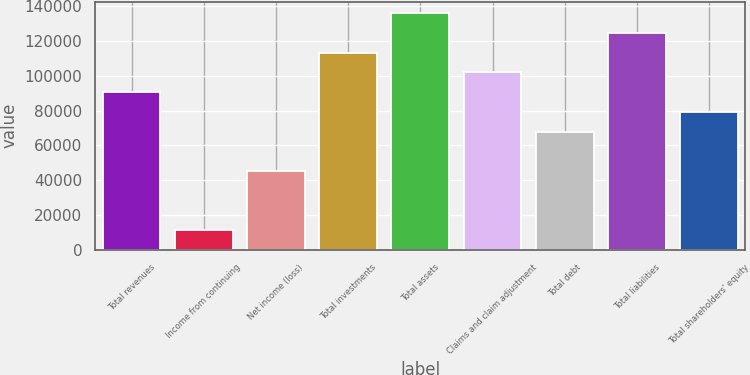<chart> <loc_0><loc_0><loc_500><loc_500><bar_chart><fcel>Total revenues<fcel>Income from continuing<fcel>Net income (loss)<fcel>Total investments<fcel>Total assets<fcel>Claims and claim adjustment<fcel>Total debt<fcel>Total liabilities<fcel>Total shareholders' equity<nl><fcel>90549.8<fcel>11319.5<fcel>45275.3<fcel>113187<fcel>135824<fcel>101868<fcel>67912.6<fcel>124506<fcel>79231.2<nl></chart> 